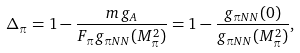<formula> <loc_0><loc_0><loc_500><loc_500>\Delta _ { \pi } = 1 - \frac { m \, g _ { A } } { F _ { \pi } g _ { \pi N N } ( M _ { \pi } ^ { 2 } ) } = 1 - \frac { g _ { \pi N N } ( 0 ) } { g _ { \pi N N } ( M _ { \pi } ^ { 2 } ) } ,</formula> 